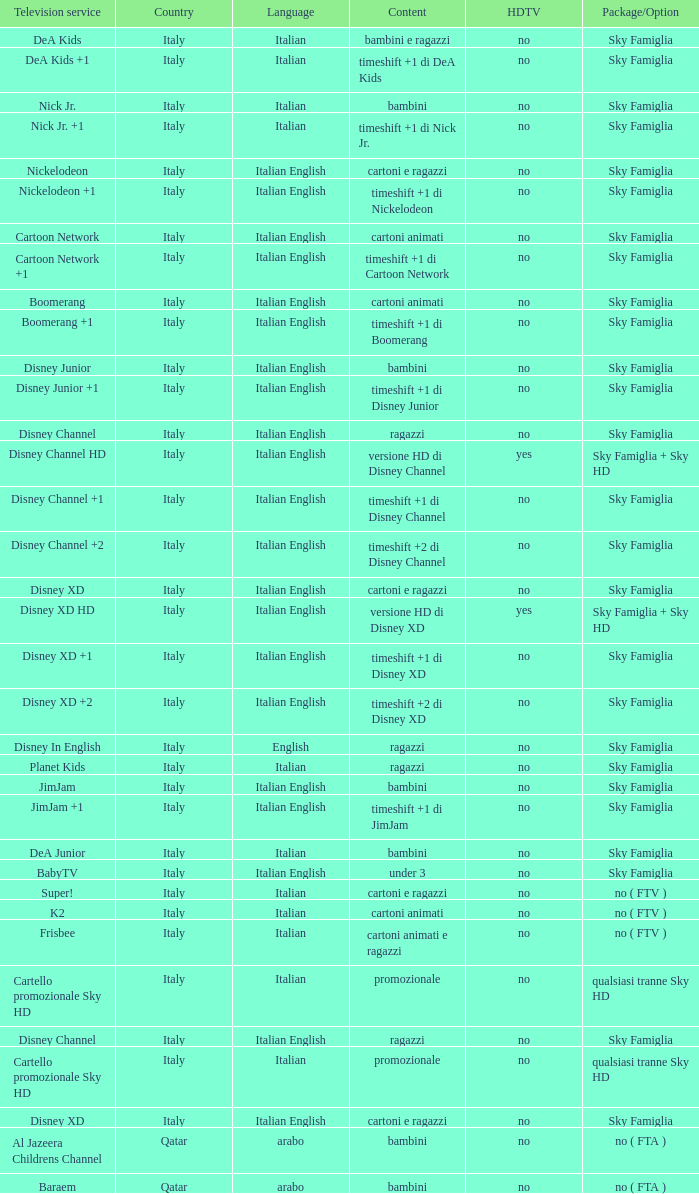Would you be able to parse every entry in this table? {'header': ['Television service', 'Country', 'Language', 'Content', 'HDTV', 'Package/Option'], 'rows': [['DeA Kids', 'Italy', 'Italian', 'bambini e ragazzi', 'no', 'Sky Famiglia'], ['DeA Kids +1', 'Italy', 'Italian', 'timeshift +1 di DeA Kids', 'no', 'Sky Famiglia'], ['Nick Jr.', 'Italy', 'Italian', 'bambini', 'no', 'Sky Famiglia'], ['Nick Jr. +1', 'Italy', 'Italian', 'timeshift +1 di Nick Jr.', 'no', 'Sky Famiglia'], ['Nickelodeon', 'Italy', 'Italian English', 'cartoni e ragazzi', 'no', 'Sky Famiglia'], ['Nickelodeon +1', 'Italy', 'Italian English', 'timeshift +1 di Nickelodeon', 'no', 'Sky Famiglia'], ['Cartoon Network', 'Italy', 'Italian English', 'cartoni animati', 'no', 'Sky Famiglia'], ['Cartoon Network +1', 'Italy', 'Italian English', 'timeshift +1 di Cartoon Network', 'no', 'Sky Famiglia'], ['Boomerang', 'Italy', 'Italian English', 'cartoni animati', 'no', 'Sky Famiglia'], ['Boomerang +1', 'Italy', 'Italian English', 'timeshift +1 di Boomerang', 'no', 'Sky Famiglia'], ['Disney Junior', 'Italy', 'Italian English', 'bambini', 'no', 'Sky Famiglia'], ['Disney Junior +1', 'Italy', 'Italian English', 'timeshift +1 di Disney Junior', 'no', 'Sky Famiglia'], ['Disney Channel', 'Italy', 'Italian English', 'ragazzi', 'no', 'Sky Famiglia'], ['Disney Channel HD', 'Italy', 'Italian English', 'versione HD di Disney Channel', 'yes', 'Sky Famiglia + Sky HD'], ['Disney Channel +1', 'Italy', 'Italian English', 'timeshift +1 di Disney Channel', 'no', 'Sky Famiglia'], ['Disney Channel +2', 'Italy', 'Italian English', 'timeshift +2 di Disney Channel', 'no', 'Sky Famiglia'], ['Disney XD', 'Italy', 'Italian English', 'cartoni e ragazzi', 'no', 'Sky Famiglia'], ['Disney XD HD', 'Italy', 'Italian English', 'versione HD di Disney XD', 'yes', 'Sky Famiglia + Sky HD'], ['Disney XD +1', 'Italy', 'Italian English', 'timeshift +1 di Disney XD', 'no', 'Sky Famiglia'], ['Disney XD +2', 'Italy', 'Italian English', 'timeshift +2 di Disney XD', 'no', 'Sky Famiglia'], ['Disney In English', 'Italy', 'English', 'ragazzi', 'no', 'Sky Famiglia'], ['Planet Kids', 'Italy', 'Italian', 'ragazzi', 'no', 'Sky Famiglia'], ['JimJam', 'Italy', 'Italian English', 'bambini', 'no', 'Sky Famiglia'], ['JimJam +1', 'Italy', 'Italian English', 'timeshift +1 di JimJam', 'no', 'Sky Famiglia'], ['DeA Junior', 'Italy', 'Italian', 'bambini', 'no', 'Sky Famiglia'], ['BabyTV', 'Italy', 'Italian English', 'under 3', 'no', 'Sky Famiglia'], ['Super!', 'Italy', 'Italian', 'cartoni e ragazzi', 'no', 'no ( FTV )'], ['K2', 'Italy', 'Italian', 'cartoni animati', 'no', 'no ( FTV )'], ['Frisbee', 'Italy', 'Italian', 'cartoni animati e ragazzi', 'no', 'no ( FTV )'], ['Cartello promozionale Sky HD', 'Italy', 'Italian', 'promozionale', 'no', 'qualsiasi tranne Sky HD'], ['Disney Channel', 'Italy', 'Italian English', 'ragazzi', 'no', 'Sky Famiglia'], ['Cartello promozionale Sky HD', 'Italy', 'Italian', 'promozionale', 'no', 'qualsiasi tranne Sky HD'], ['Disney XD', 'Italy', 'Italian English', 'cartoni e ragazzi', 'no', 'Sky Famiglia'], ['Al Jazeera Childrens Channel', 'Qatar', 'arabo', 'bambini', 'no', 'no ( FTA )'], ['Baraem', 'Qatar', 'arabo', 'bambini', 'no', 'no ( FTA )']]} What shows as Content for the Television service of nickelodeon +1? Timeshift +1 di nickelodeon. 